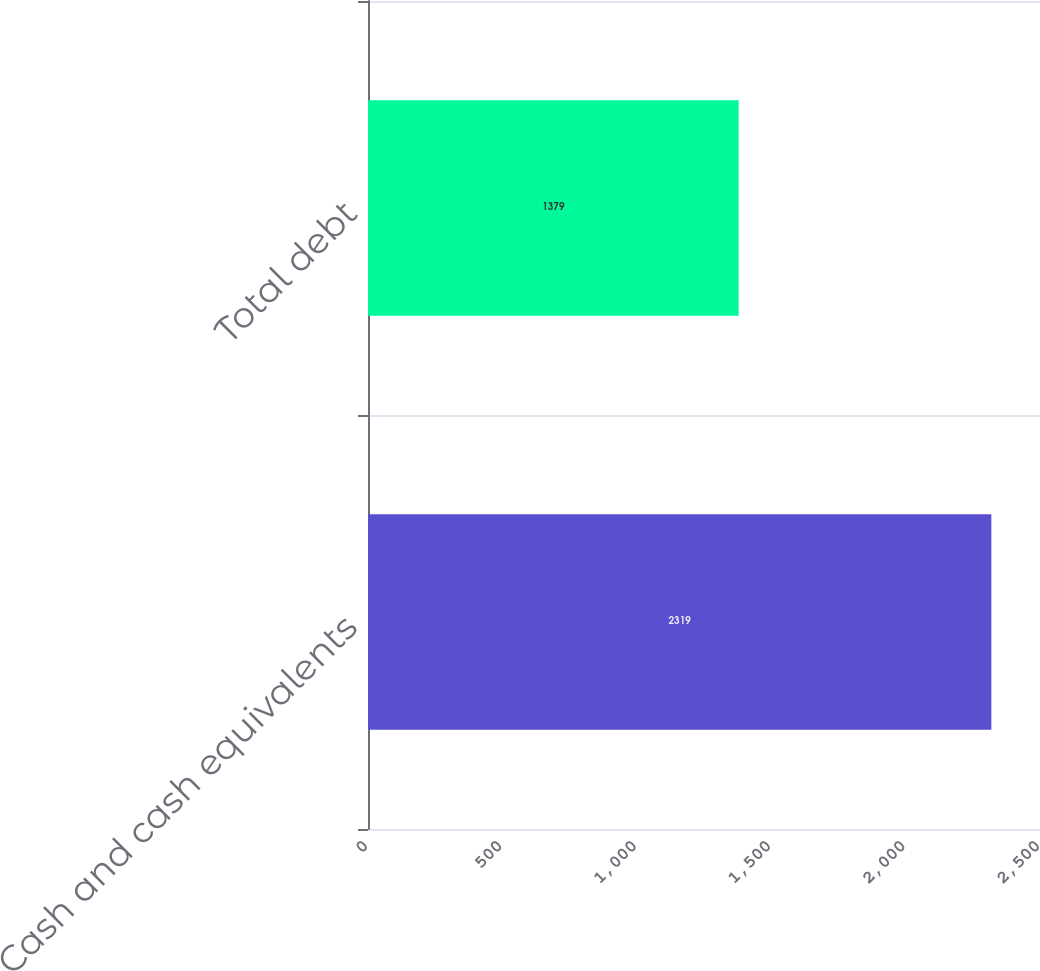<chart> <loc_0><loc_0><loc_500><loc_500><bar_chart><fcel>Cash and cash equivalents<fcel>Total debt<nl><fcel>2319<fcel>1379<nl></chart> 